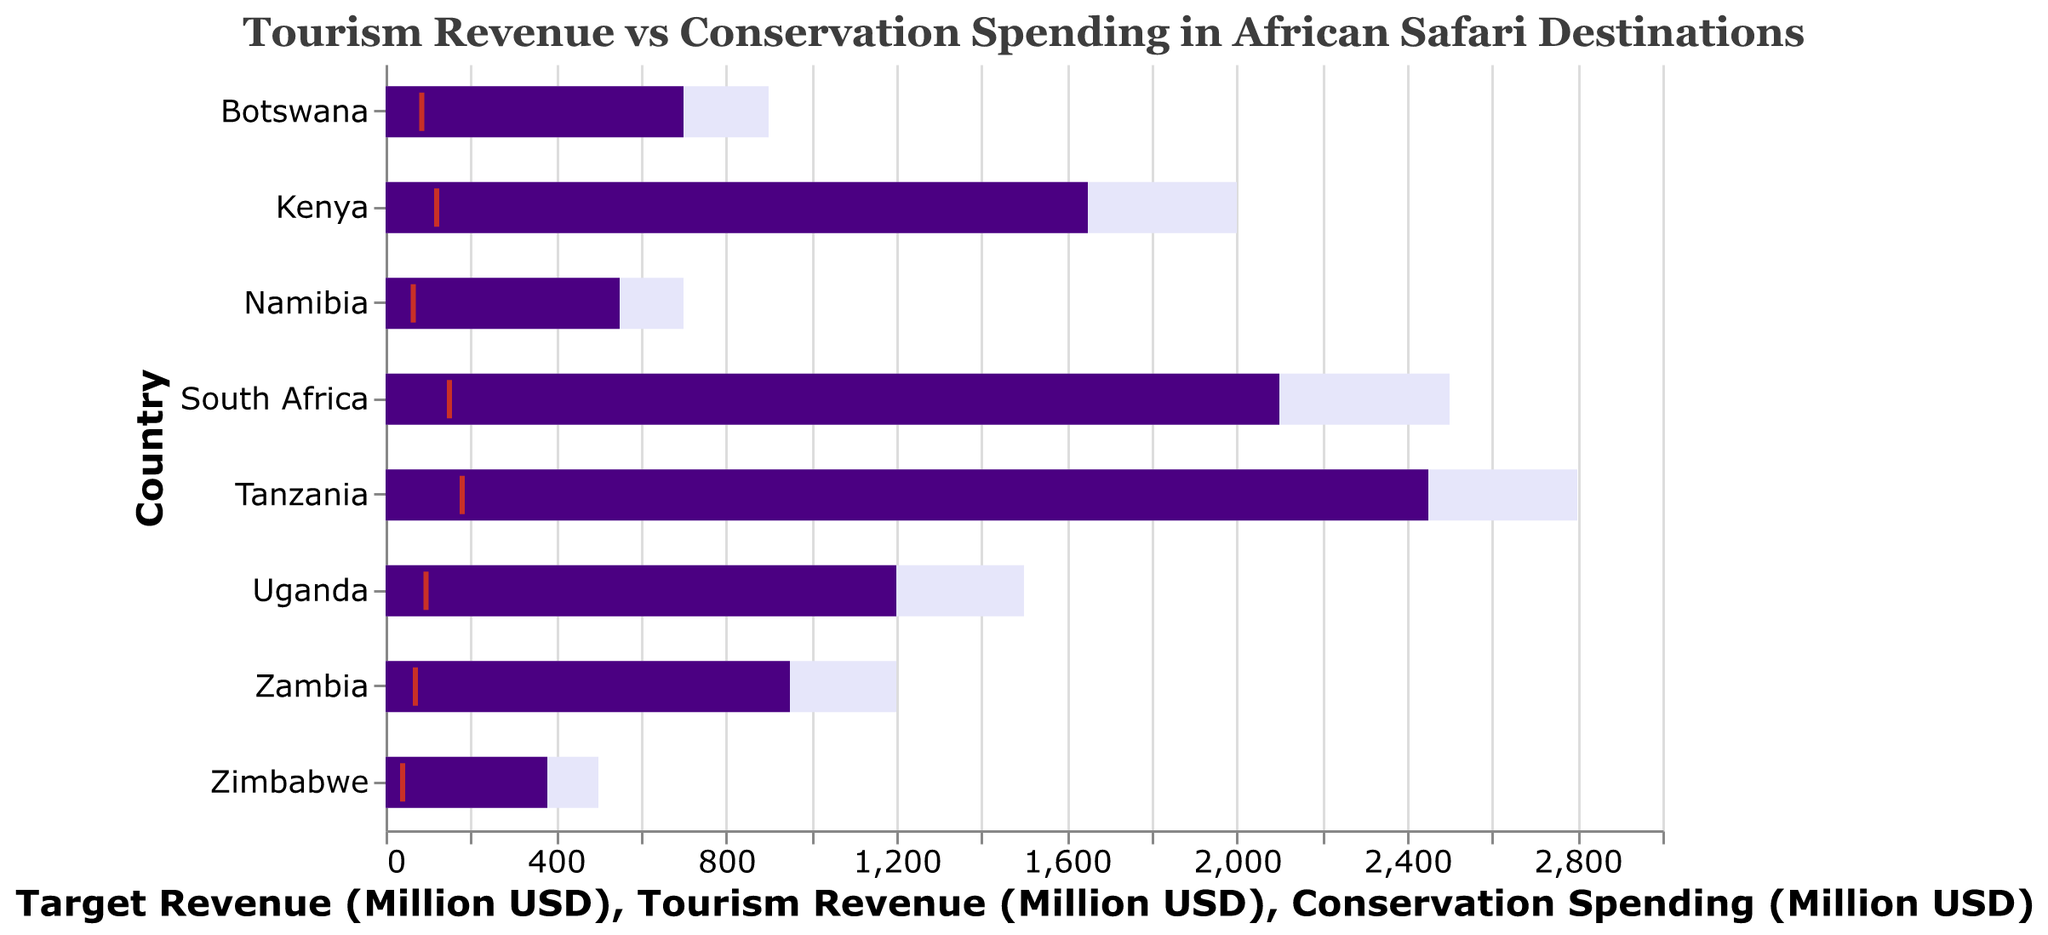What is the title of the chart? The title is displayed at the top of the chart, describing the content clearly.
Answer: Tourism Revenue vs Conservation Spending in African Safari Destinations How many countries are represented in the chart? Counting the unique country names along the y-axis gives us the number of countries represented.
Answer: 8 Which country has the highest tourism revenue? By comparing the lengths of the purple bars, the longest represents the highest value.
Answer: Tanzania Which country has the lowest conservation spending? By comparing the positions of the orange ticks, the furthest left represents the lowest spending.
Answer: Zimbabwe Did any country meet their target tourism revenue? No bar reaches or exceeds the length of the grey area that represents the target revenue.
Answer: No How much more is Tanzania's target revenue compared to Botswana’s target revenue? Subtract Botswana's target revenue (900) from Tanzania's target revenue (2800).
Answer: 1900 Which country has the closest actual tourism revenue to its target revenue? Compare the lengths of the purple bars to their corresponding grey areas to see the smallest gap.
Answer: South Africa What is the difference between Uganda’s tourism revenue and its conservation spending? Subtract Uganda’s conservation spending (95) from its tourism revenue (1200).
Answer: 1105 How does South Africa’s conservation spending compare to that of Kenya? Compare the positions of the orange ticks for both countries along the x-axis.
Answer: South Africa has higher conservation spending than Kenya What is the average conservation spending of all the countries? Sum all conservation spending values and divide by the number of countries: (120 + 180 + 150 + 85 + 65 + 40 + 95 + 70)/8.
Answer: 100.625 